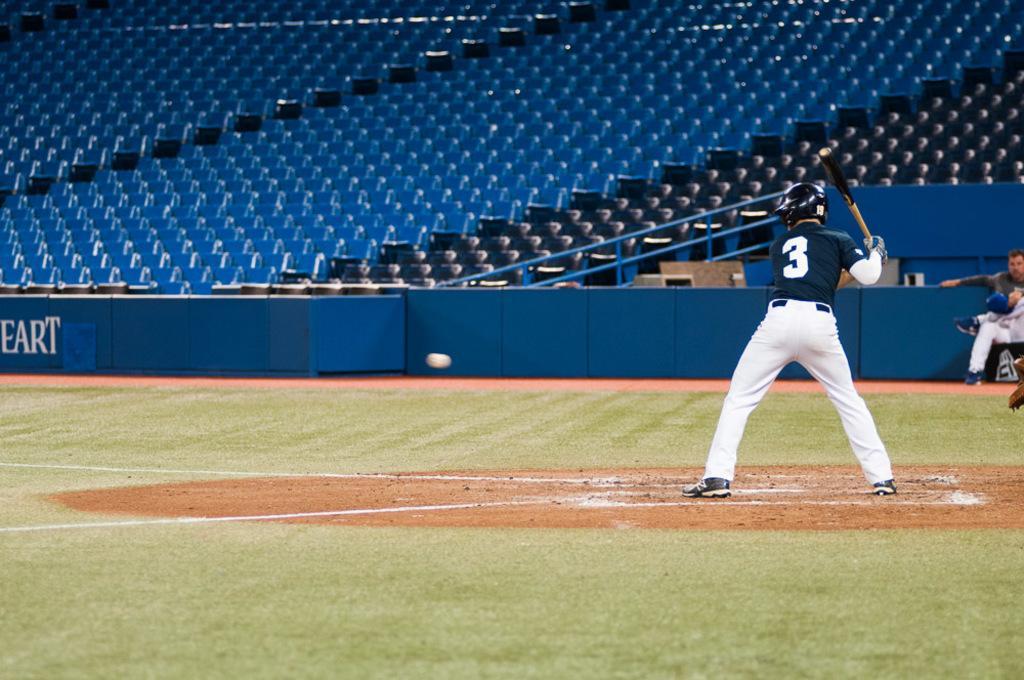Describe this image in one or two sentences. In this picture there is a man standing and holding a bat and wore helmet. We can see grass and ground. In the background of the image there is a man sitting and we can see hoarding, railing and chairs. 